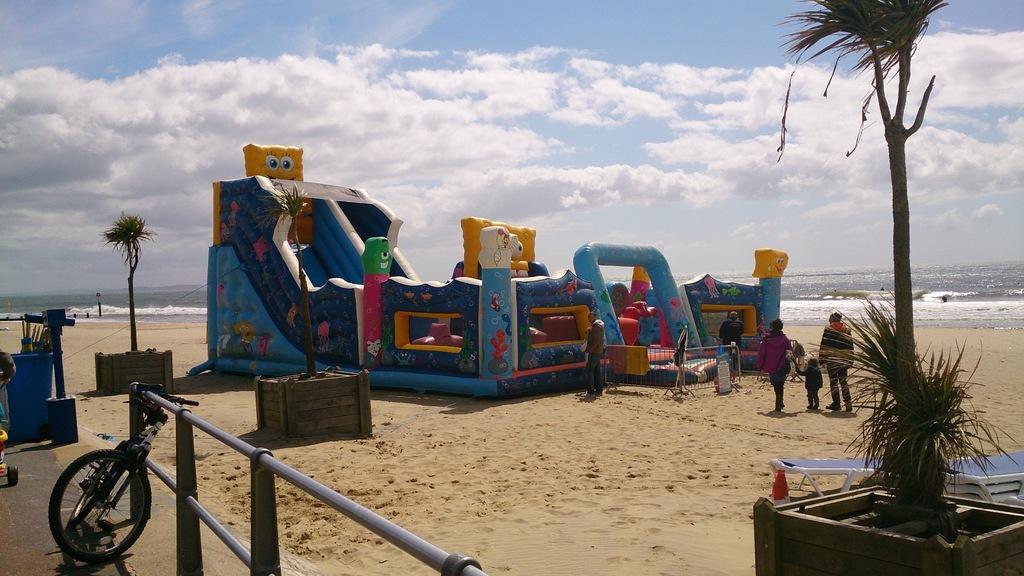Can you describe this image briefly? This picture is clicked outside. In the center there is an inflatable slide and we can see the trees, group of persons, metal rods, bicycle, water body and many other objects and we can see the wooden objects. In the background there is a sky which is full of clouds. 